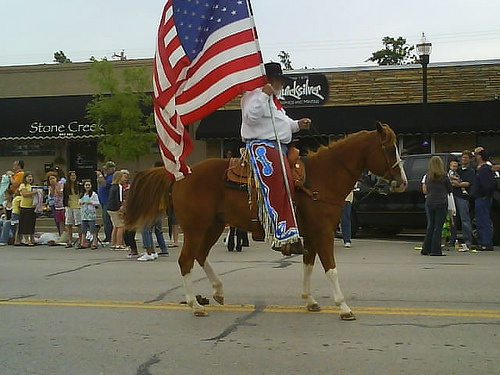Describe the objects in this image and their specific colors. I can see horse in lightblue, black, maroon, and gray tones, people in lightblue, darkgray, maroon, black, and gray tones, people in lightblue, black, gray, and darkgreen tones, truck in lightblue, black, gray, and purple tones, and people in lightblue, black, darkgreen, and gray tones in this image. 